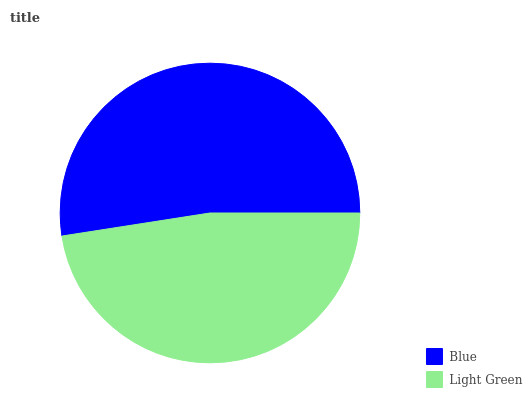Is Light Green the minimum?
Answer yes or no. Yes. Is Blue the maximum?
Answer yes or no. Yes. Is Light Green the maximum?
Answer yes or no. No. Is Blue greater than Light Green?
Answer yes or no. Yes. Is Light Green less than Blue?
Answer yes or no. Yes. Is Light Green greater than Blue?
Answer yes or no. No. Is Blue less than Light Green?
Answer yes or no. No. Is Blue the high median?
Answer yes or no. Yes. Is Light Green the low median?
Answer yes or no. Yes. Is Light Green the high median?
Answer yes or no. No. Is Blue the low median?
Answer yes or no. No. 